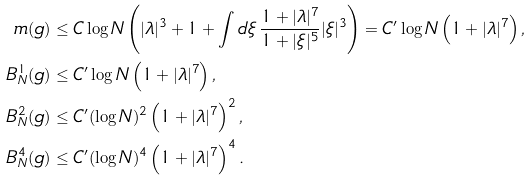Convert formula to latex. <formula><loc_0><loc_0><loc_500><loc_500>m ( g ) & \leq C \log N \left ( | \lambda | ^ { 3 } + 1 + \int d \xi \, \frac { 1 + | \lambda | ^ { 7 } } { 1 + | \xi | ^ { 5 } } | \xi | ^ { 3 } \right ) = C ^ { \prime } \log N \left ( 1 + | \lambda | ^ { 7 } \right ) , \\ B _ { N } ^ { 1 } ( g ) & \leq C ^ { \prime } \log N \left ( 1 + | \lambda | ^ { 7 } \right ) , \\ B _ { N } ^ { 2 } ( g ) & \leq C ^ { \prime } ( \log N ) ^ { 2 } \left ( 1 + | \lambda | ^ { 7 } \right ) ^ { 2 } , \\ B _ { N } ^ { 4 } ( g ) & \leq C ^ { \prime } ( \log N ) ^ { 4 } \left ( 1 + | \lambda | ^ { 7 } \right ) ^ { 4 } . \\</formula> 